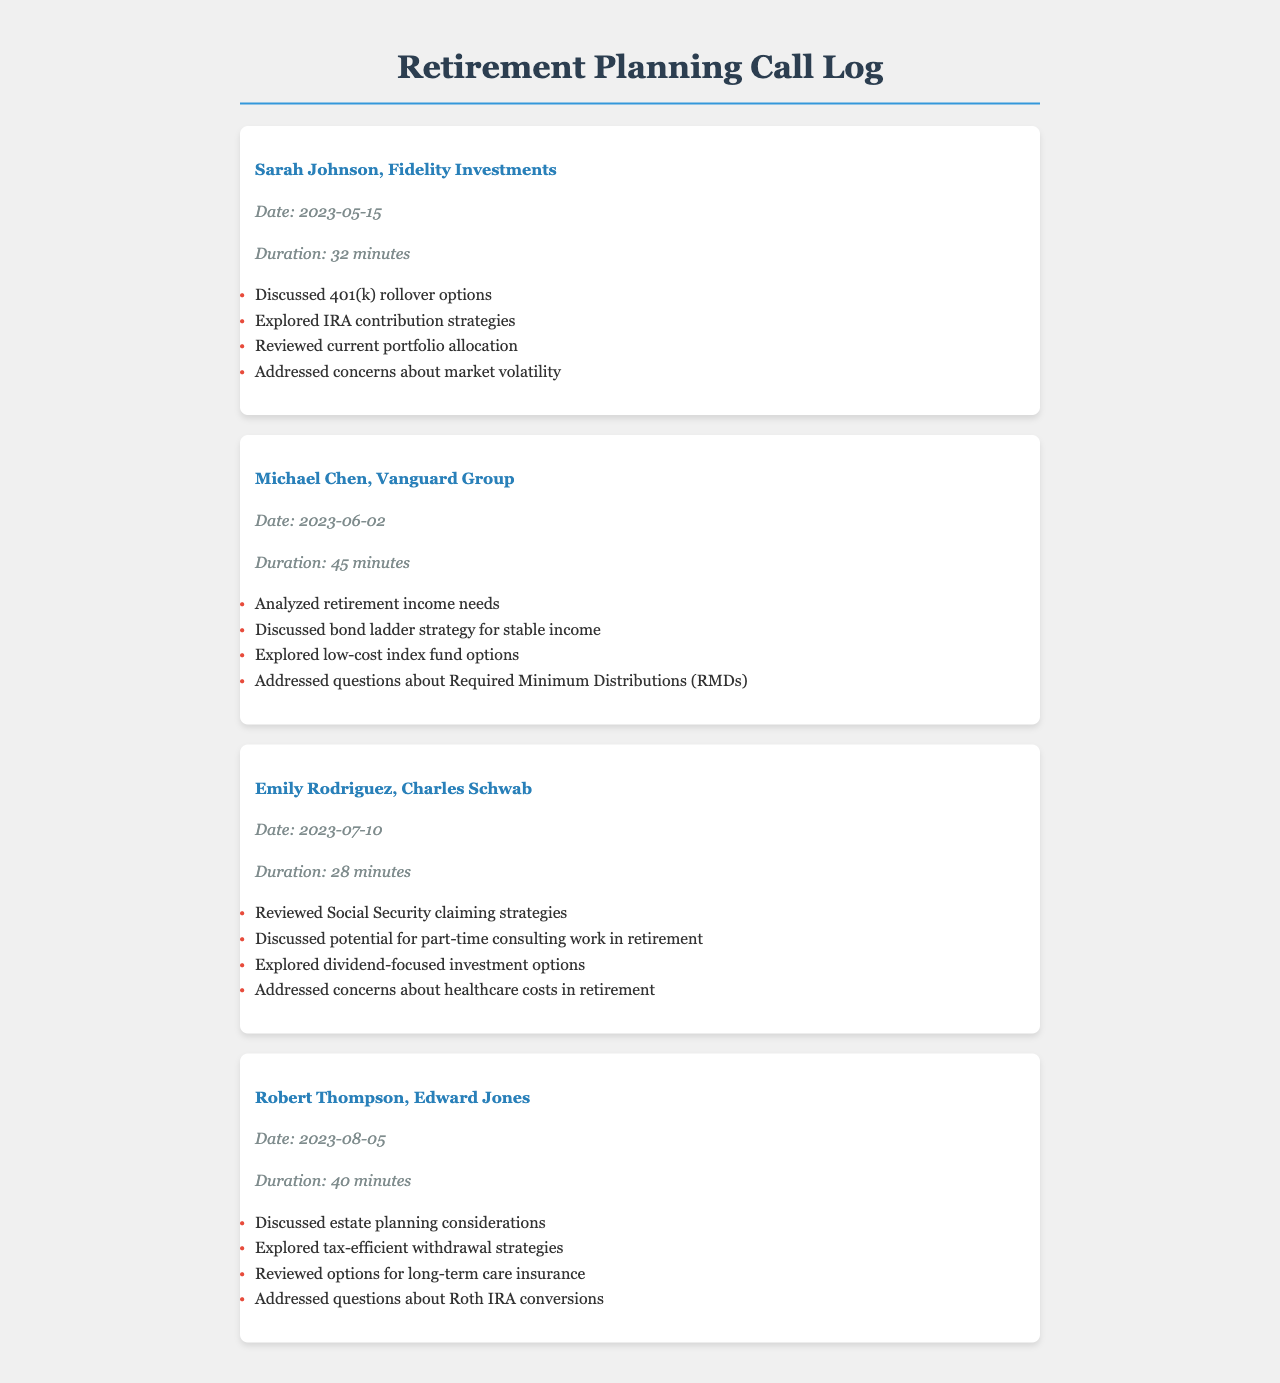what is the name of the first advisor? The name of the first advisor listed in the document is Sarah Johnson.
Answer: Sarah Johnson what date did Michael Chen's call take place? The date of Michael Chen's call is found within the document under his call log, which states "Date: 2023-06-02".
Answer: 2023-06-02 how long was the call with Emily Rodriguez? The duration of Emily Rodriguez's call is mentioned as "Duration: 28 minutes".
Answer: 28 minutes what investment strategy was discussed during Robert Thompson's call? One of the strategies mentioned in Robert Thompson's call log was "tax-efficient withdrawal strategies".
Answer: tax-efficient withdrawal strategies how many minutes was Sarah Johnson's call? The duration of Sarah Johnson's call is provided in the document as "32 minutes".
Answer: 32 minutes which advisor discussed estate planning considerations? The advisor who discussed estate planning considerations is Robert Thompson.
Answer: Robert Thompson what was one of the main topics covered during Michael Chen's call? One of the main topics covered during Michael Chen's call was "analyzed retirement income needs".
Answer: analyzed retirement income needs how many call logs are included in the document? The document contains four call logs listed for different advisors.
Answer: four 